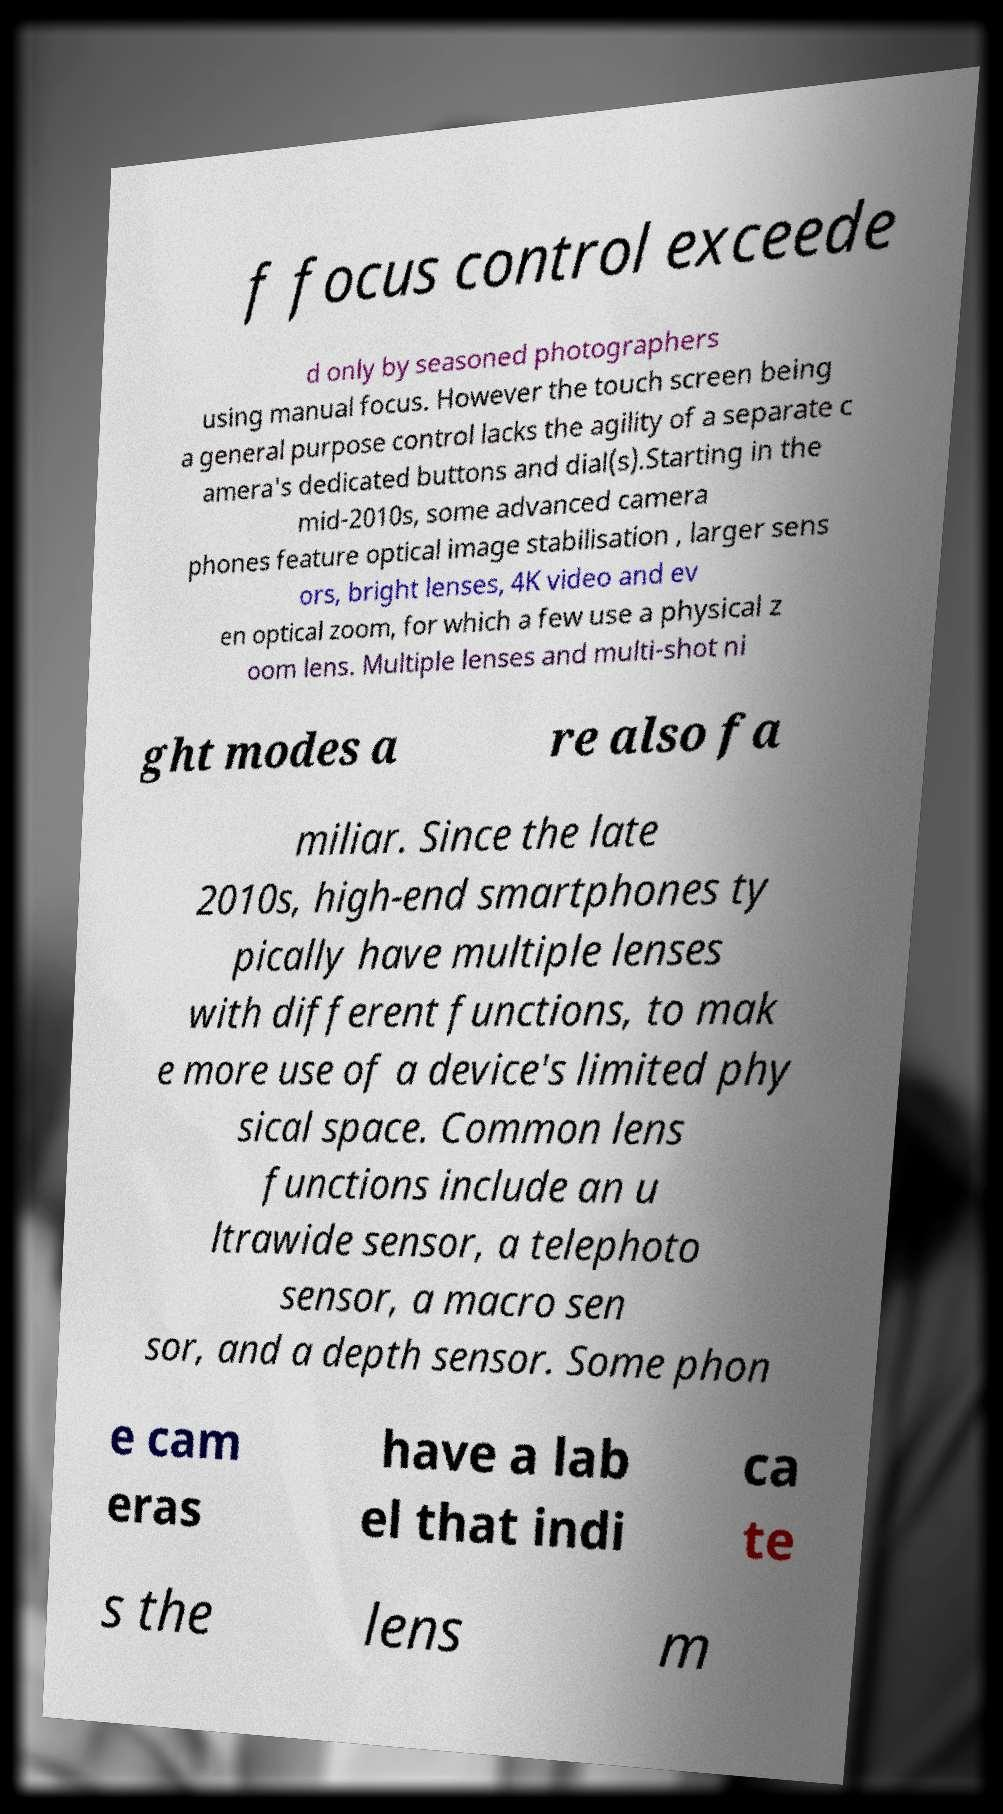There's text embedded in this image that I need extracted. Can you transcribe it verbatim? f focus control exceede d only by seasoned photographers using manual focus. However the touch screen being a general purpose control lacks the agility of a separate c amera's dedicated buttons and dial(s).Starting in the mid-2010s, some advanced camera phones feature optical image stabilisation , larger sens ors, bright lenses, 4K video and ev en optical zoom, for which a few use a physical z oom lens. Multiple lenses and multi-shot ni ght modes a re also fa miliar. Since the late 2010s, high-end smartphones ty pically have multiple lenses with different functions, to mak e more use of a device's limited phy sical space. Common lens functions include an u ltrawide sensor, a telephoto sensor, a macro sen sor, and a depth sensor. Some phon e cam eras have a lab el that indi ca te s the lens m 